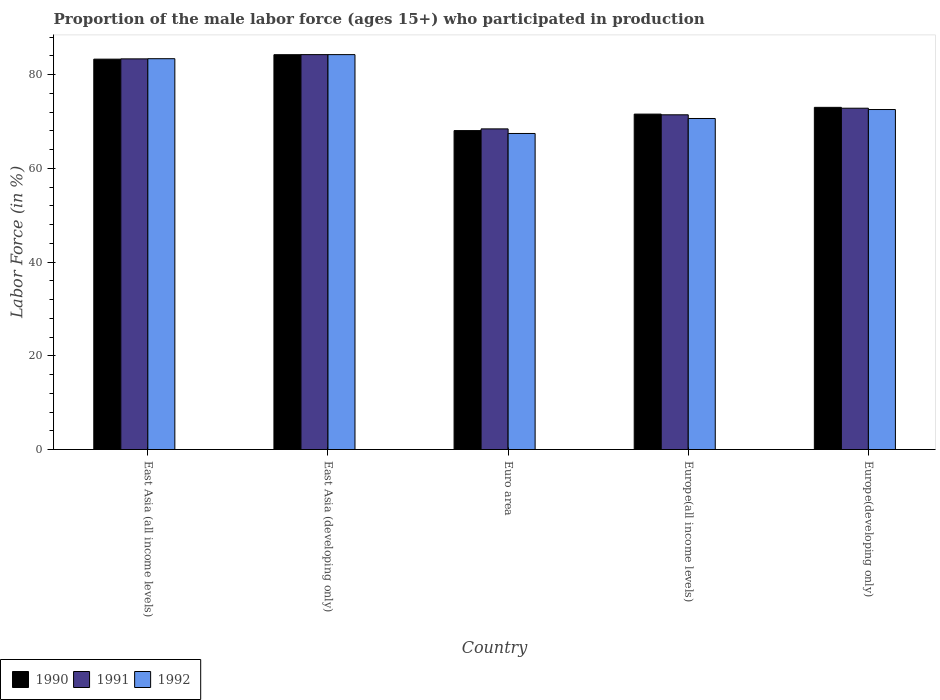How many bars are there on the 4th tick from the left?
Your answer should be very brief. 3. How many bars are there on the 5th tick from the right?
Offer a very short reply. 3. What is the label of the 5th group of bars from the left?
Give a very brief answer. Europe(developing only). In how many cases, is the number of bars for a given country not equal to the number of legend labels?
Your answer should be compact. 0. What is the proportion of the male labor force who participated in production in 1991 in East Asia (developing only)?
Keep it short and to the point. 84.25. Across all countries, what is the maximum proportion of the male labor force who participated in production in 1992?
Your response must be concise. 84.25. Across all countries, what is the minimum proportion of the male labor force who participated in production in 1992?
Ensure brevity in your answer.  67.42. In which country was the proportion of the male labor force who participated in production in 1990 maximum?
Offer a very short reply. East Asia (developing only). In which country was the proportion of the male labor force who participated in production in 1992 minimum?
Provide a short and direct response. Euro area. What is the total proportion of the male labor force who participated in production in 1991 in the graph?
Give a very brief answer. 380.22. What is the difference between the proportion of the male labor force who participated in production in 1990 in East Asia (all income levels) and that in Europe(developing only)?
Ensure brevity in your answer.  10.28. What is the difference between the proportion of the male labor force who participated in production in 1990 in Europe(developing only) and the proportion of the male labor force who participated in production in 1992 in Euro area?
Ensure brevity in your answer.  5.58. What is the average proportion of the male labor force who participated in production in 1991 per country?
Offer a very short reply. 76.04. What is the difference between the proportion of the male labor force who participated in production of/in 1991 and proportion of the male labor force who participated in production of/in 1990 in East Asia (all income levels)?
Your answer should be very brief. 0.06. In how many countries, is the proportion of the male labor force who participated in production in 1992 greater than 52 %?
Your answer should be very brief. 5. What is the ratio of the proportion of the male labor force who participated in production in 1990 in Euro area to that in Europe(all income levels)?
Keep it short and to the point. 0.95. Is the proportion of the male labor force who participated in production in 1992 in Euro area less than that in Europe(all income levels)?
Provide a short and direct response. Yes. What is the difference between the highest and the second highest proportion of the male labor force who participated in production in 1992?
Your answer should be compact. -10.85. What is the difference between the highest and the lowest proportion of the male labor force who participated in production in 1992?
Make the answer very short. 16.83. Is the sum of the proportion of the male labor force who participated in production in 1991 in East Asia (all income levels) and Euro area greater than the maximum proportion of the male labor force who participated in production in 1992 across all countries?
Your answer should be compact. Yes. What does the 2nd bar from the left in East Asia (developing only) represents?
Your answer should be very brief. 1991. What does the 1st bar from the right in Europe(developing only) represents?
Your response must be concise. 1992. How many bars are there?
Your response must be concise. 15. How many countries are there in the graph?
Give a very brief answer. 5. What is the difference between two consecutive major ticks on the Y-axis?
Your response must be concise. 20. Are the values on the major ticks of Y-axis written in scientific E-notation?
Offer a terse response. No. Does the graph contain any zero values?
Your response must be concise. No. Does the graph contain grids?
Your answer should be very brief. No. Where does the legend appear in the graph?
Your response must be concise. Bottom left. How many legend labels are there?
Ensure brevity in your answer.  3. What is the title of the graph?
Your answer should be compact. Proportion of the male labor force (ages 15+) who participated in production. What is the Labor Force (in %) of 1990 in East Asia (all income levels)?
Give a very brief answer. 83.28. What is the Labor Force (in %) in 1991 in East Asia (all income levels)?
Keep it short and to the point. 83.34. What is the Labor Force (in %) in 1992 in East Asia (all income levels)?
Your response must be concise. 83.38. What is the Labor Force (in %) in 1990 in East Asia (developing only)?
Your answer should be very brief. 84.23. What is the Labor Force (in %) in 1991 in East Asia (developing only)?
Provide a short and direct response. 84.25. What is the Labor Force (in %) in 1992 in East Asia (developing only)?
Your response must be concise. 84.25. What is the Labor Force (in %) in 1990 in Euro area?
Your answer should be very brief. 68.04. What is the Labor Force (in %) in 1991 in Euro area?
Provide a succinct answer. 68.4. What is the Labor Force (in %) in 1992 in Euro area?
Your answer should be compact. 67.42. What is the Labor Force (in %) of 1990 in Europe(all income levels)?
Offer a very short reply. 71.56. What is the Labor Force (in %) of 1991 in Europe(all income levels)?
Offer a terse response. 71.41. What is the Labor Force (in %) in 1992 in Europe(all income levels)?
Your answer should be compact. 70.62. What is the Labor Force (in %) of 1990 in Europe(developing only)?
Keep it short and to the point. 73. What is the Labor Force (in %) of 1991 in Europe(developing only)?
Provide a short and direct response. 72.82. What is the Labor Force (in %) in 1992 in Europe(developing only)?
Your answer should be very brief. 72.53. Across all countries, what is the maximum Labor Force (in %) in 1990?
Offer a terse response. 84.23. Across all countries, what is the maximum Labor Force (in %) of 1991?
Give a very brief answer. 84.25. Across all countries, what is the maximum Labor Force (in %) in 1992?
Your response must be concise. 84.25. Across all countries, what is the minimum Labor Force (in %) of 1990?
Offer a terse response. 68.04. Across all countries, what is the minimum Labor Force (in %) of 1991?
Ensure brevity in your answer.  68.4. Across all countries, what is the minimum Labor Force (in %) of 1992?
Offer a very short reply. 67.42. What is the total Labor Force (in %) in 1990 in the graph?
Ensure brevity in your answer.  380.12. What is the total Labor Force (in %) of 1991 in the graph?
Your answer should be compact. 380.22. What is the total Labor Force (in %) in 1992 in the graph?
Give a very brief answer. 378.21. What is the difference between the Labor Force (in %) of 1990 in East Asia (all income levels) and that in East Asia (developing only)?
Keep it short and to the point. -0.95. What is the difference between the Labor Force (in %) of 1991 in East Asia (all income levels) and that in East Asia (developing only)?
Provide a short and direct response. -0.91. What is the difference between the Labor Force (in %) in 1992 in East Asia (all income levels) and that in East Asia (developing only)?
Ensure brevity in your answer.  -0.87. What is the difference between the Labor Force (in %) of 1990 in East Asia (all income levels) and that in Euro area?
Your response must be concise. 15.24. What is the difference between the Labor Force (in %) of 1991 in East Asia (all income levels) and that in Euro area?
Provide a short and direct response. 14.94. What is the difference between the Labor Force (in %) in 1992 in East Asia (all income levels) and that in Euro area?
Give a very brief answer. 15.96. What is the difference between the Labor Force (in %) of 1990 in East Asia (all income levels) and that in Europe(all income levels)?
Your answer should be compact. 11.72. What is the difference between the Labor Force (in %) in 1991 in East Asia (all income levels) and that in Europe(all income levels)?
Keep it short and to the point. 11.93. What is the difference between the Labor Force (in %) of 1992 in East Asia (all income levels) and that in Europe(all income levels)?
Keep it short and to the point. 12.76. What is the difference between the Labor Force (in %) in 1990 in East Asia (all income levels) and that in Europe(developing only)?
Ensure brevity in your answer.  10.28. What is the difference between the Labor Force (in %) in 1991 in East Asia (all income levels) and that in Europe(developing only)?
Keep it short and to the point. 10.53. What is the difference between the Labor Force (in %) in 1992 in East Asia (all income levels) and that in Europe(developing only)?
Offer a very short reply. 10.85. What is the difference between the Labor Force (in %) of 1990 in East Asia (developing only) and that in Euro area?
Provide a short and direct response. 16.19. What is the difference between the Labor Force (in %) of 1991 in East Asia (developing only) and that in Euro area?
Your answer should be compact. 15.84. What is the difference between the Labor Force (in %) in 1992 in East Asia (developing only) and that in Euro area?
Keep it short and to the point. 16.83. What is the difference between the Labor Force (in %) in 1990 in East Asia (developing only) and that in Europe(all income levels)?
Provide a short and direct response. 12.67. What is the difference between the Labor Force (in %) of 1991 in East Asia (developing only) and that in Europe(all income levels)?
Your answer should be very brief. 12.84. What is the difference between the Labor Force (in %) in 1992 in East Asia (developing only) and that in Europe(all income levels)?
Give a very brief answer. 13.63. What is the difference between the Labor Force (in %) in 1990 in East Asia (developing only) and that in Europe(developing only)?
Your answer should be very brief. 11.23. What is the difference between the Labor Force (in %) in 1991 in East Asia (developing only) and that in Europe(developing only)?
Make the answer very short. 11.43. What is the difference between the Labor Force (in %) in 1992 in East Asia (developing only) and that in Europe(developing only)?
Offer a terse response. 11.71. What is the difference between the Labor Force (in %) in 1990 in Euro area and that in Europe(all income levels)?
Offer a very short reply. -3.52. What is the difference between the Labor Force (in %) of 1991 in Euro area and that in Europe(all income levels)?
Your response must be concise. -3. What is the difference between the Labor Force (in %) of 1992 in Euro area and that in Europe(all income levels)?
Make the answer very short. -3.2. What is the difference between the Labor Force (in %) of 1990 in Euro area and that in Europe(developing only)?
Keep it short and to the point. -4.96. What is the difference between the Labor Force (in %) of 1991 in Euro area and that in Europe(developing only)?
Keep it short and to the point. -4.41. What is the difference between the Labor Force (in %) of 1992 in Euro area and that in Europe(developing only)?
Make the answer very short. -5.11. What is the difference between the Labor Force (in %) in 1990 in Europe(all income levels) and that in Europe(developing only)?
Give a very brief answer. -1.44. What is the difference between the Labor Force (in %) of 1991 in Europe(all income levels) and that in Europe(developing only)?
Offer a very short reply. -1.41. What is the difference between the Labor Force (in %) in 1992 in Europe(all income levels) and that in Europe(developing only)?
Give a very brief answer. -1.91. What is the difference between the Labor Force (in %) of 1990 in East Asia (all income levels) and the Labor Force (in %) of 1991 in East Asia (developing only)?
Your answer should be compact. -0.97. What is the difference between the Labor Force (in %) of 1990 in East Asia (all income levels) and the Labor Force (in %) of 1992 in East Asia (developing only)?
Make the answer very short. -0.97. What is the difference between the Labor Force (in %) in 1991 in East Asia (all income levels) and the Labor Force (in %) in 1992 in East Asia (developing only)?
Offer a very short reply. -0.91. What is the difference between the Labor Force (in %) of 1990 in East Asia (all income levels) and the Labor Force (in %) of 1991 in Euro area?
Provide a succinct answer. 14.88. What is the difference between the Labor Force (in %) of 1990 in East Asia (all income levels) and the Labor Force (in %) of 1992 in Euro area?
Your answer should be very brief. 15.86. What is the difference between the Labor Force (in %) of 1991 in East Asia (all income levels) and the Labor Force (in %) of 1992 in Euro area?
Keep it short and to the point. 15.92. What is the difference between the Labor Force (in %) of 1990 in East Asia (all income levels) and the Labor Force (in %) of 1991 in Europe(all income levels)?
Offer a very short reply. 11.87. What is the difference between the Labor Force (in %) of 1990 in East Asia (all income levels) and the Labor Force (in %) of 1992 in Europe(all income levels)?
Provide a succinct answer. 12.66. What is the difference between the Labor Force (in %) of 1991 in East Asia (all income levels) and the Labor Force (in %) of 1992 in Europe(all income levels)?
Keep it short and to the point. 12.72. What is the difference between the Labor Force (in %) in 1990 in East Asia (all income levels) and the Labor Force (in %) in 1991 in Europe(developing only)?
Provide a short and direct response. 10.47. What is the difference between the Labor Force (in %) in 1990 in East Asia (all income levels) and the Labor Force (in %) in 1992 in Europe(developing only)?
Provide a succinct answer. 10.75. What is the difference between the Labor Force (in %) of 1991 in East Asia (all income levels) and the Labor Force (in %) of 1992 in Europe(developing only)?
Offer a very short reply. 10.81. What is the difference between the Labor Force (in %) of 1990 in East Asia (developing only) and the Labor Force (in %) of 1991 in Euro area?
Make the answer very short. 15.83. What is the difference between the Labor Force (in %) in 1990 in East Asia (developing only) and the Labor Force (in %) in 1992 in Euro area?
Ensure brevity in your answer.  16.81. What is the difference between the Labor Force (in %) of 1991 in East Asia (developing only) and the Labor Force (in %) of 1992 in Euro area?
Your answer should be compact. 16.82. What is the difference between the Labor Force (in %) in 1990 in East Asia (developing only) and the Labor Force (in %) in 1991 in Europe(all income levels)?
Provide a succinct answer. 12.82. What is the difference between the Labor Force (in %) of 1990 in East Asia (developing only) and the Labor Force (in %) of 1992 in Europe(all income levels)?
Offer a terse response. 13.61. What is the difference between the Labor Force (in %) in 1991 in East Asia (developing only) and the Labor Force (in %) in 1992 in Europe(all income levels)?
Offer a terse response. 13.63. What is the difference between the Labor Force (in %) in 1990 in East Asia (developing only) and the Labor Force (in %) in 1991 in Europe(developing only)?
Make the answer very short. 11.42. What is the difference between the Labor Force (in %) of 1990 in East Asia (developing only) and the Labor Force (in %) of 1992 in Europe(developing only)?
Your answer should be very brief. 11.7. What is the difference between the Labor Force (in %) in 1991 in East Asia (developing only) and the Labor Force (in %) in 1992 in Europe(developing only)?
Keep it short and to the point. 11.71. What is the difference between the Labor Force (in %) in 1990 in Euro area and the Labor Force (in %) in 1991 in Europe(all income levels)?
Provide a short and direct response. -3.37. What is the difference between the Labor Force (in %) of 1990 in Euro area and the Labor Force (in %) of 1992 in Europe(all income levels)?
Your answer should be very brief. -2.58. What is the difference between the Labor Force (in %) in 1991 in Euro area and the Labor Force (in %) in 1992 in Europe(all income levels)?
Offer a very short reply. -2.22. What is the difference between the Labor Force (in %) in 1990 in Euro area and the Labor Force (in %) in 1991 in Europe(developing only)?
Offer a terse response. -4.78. What is the difference between the Labor Force (in %) in 1990 in Euro area and the Labor Force (in %) in 1992 in Europe(developing only)?
Your answer should be very brief. -4.49. What is the difference between the Labor Force (in %) of 1991 in Euro area and the Labor Force (in %) of 1992 in Europe(developing only)?
Your answer should be compact. -4.13. What is the difference between the Labor Force (in %) in 1990 in Europe(all income levels) and the Labor Force (in %) in 1991 in Europe(developing only)?
Your answer should be compact. -1.26. What is the difference between the Labor Force (in %) of 1990 in Europe(all income levels) and the Labor Force (in %) of 1992 in Europe(developing only)?
Your answer should be compact. -0.97. What is the difference between the Labor Force (in %) of 1991 in Europe(all income levels) and the Labor Force (in %) of 1992 in Europe(developing only)?
Your response must be concise. -1.12. What is the average Labor Force (in %) in 1990 per country?
Your answer should be compact. 76.02. What is the average Labor Force (in %) in 1991 per country?
Provide a short and direct response. 76.04. What is the average Labor Force (in %) in 1992 per country?
Your answer should be very brief. 75.64. What is the difference between the Labor Force (in %) of 1990 and Labor Force (in %) of 1991 in East Asia (all income levels)?
Provide a succinct answer. -0.06. What is the difference between the Labor Force (in %) of 1990 and Labor Force (in %) of 1992 in East Asia (all income levels)?
Provide a short and direct response. -0.1. What is the difference between the Labor Force (in %) of 1991 and Labor Force (in %) of 1992 in East Asia (all income levels)?
Keep it short and to the point. -0.04. What is the difference between the Labor Force (in %) in 1990 and Labor Force (in %) in 1991 in East Asia (developing only)?
Your answer should be compact. -0.02. What is the difference between the Labor Force (in %) in 1990 and Labor Force (in %) in 1992 in East Asia (developing only)?
Provide a succinct answer. -0.02. What is the difference between the Labor Force (in %) of 1991 and Labor Force (in %) of 1992 in East Asia (developing only)?
Offer a terse response. -0. What is the difference between the Labor Force (in %) in 1990 and Labor Force (in %) in 1991 in Euro area?
Provide a succinct answer. -0.36. What is the difference between the Labor Force (in %) of 1990 and Labor Force (in %) of 1992 in Euro area?
Your answer should be very brief. 0.62. What is the difference between the Labor Force (in %) of 1991 and Labor Force (in %) of 1992 in Euro area?
Offer a terse response. 0.98. What is the difference between the Labor Force (in %) in 1990 and Labor Force (in %) in 1991 in Europe(all income levels)?
Your answer should be very brief. 0.15. What is the difference between the Labor Force (in %) in 1990 and Labor Force (in %) in 1992 in Europe(all income levels)?
Offer a very short reply. 0.94. What is the difference between the Labor Force (in %) in 1991 and Labor Force (in %) in 1992 in Europe(all income levels)?
Give a very brief answer. 0.79. What is the difference between the Labor Force (in %) in 1990 and Labor Force (in %) in 1991 in Europe(developing only)?
Offer a terse response. 0.18. What is the difference between the Labor Force (in %) in 1990 and Labor Force (in %) in 1992 in Europe(developing only)?
Make the answer very short. 0.47. What is the difference between the Labor Force (in %) of 1991 and Labor Force (in %) of 1992 in Europe(developing only)?
Give a very brief answer. 0.28. What is the ratio of the Labor Force (in %) of 1990 in East Asia (all income levels) to that in East Asia (developing only)?
Your answer should be very brief. 0.99. What is the ratio of the Labor Force (in %) of 1991 in East Asia (all income levels) to that in East Asia (developing only)?
Provide a succinct answer. 0.99. What is the ratio of the Labor Force (in %) in 1992 in East Asia (all income levels) to that in East Asia (developing only)?
Provide a succinct answer. 0.99. What is the ratio of the Labor Force (in %) in 1990 in East Asia (all income levels) to that in Euro area?
Ensure brevity in your answer.  1.22. What is the ratio of the Labor Force (in %) of 1991 in East Asia (all income levels) to that in Euro area?
Make the answer very short. 1.22. What is the ratio of the Labor Force (in %) of 1992 in East Asia (all income levels) to that in Euro area?
Your answer should be compact. 1.24. What is the ratio of the Labor Force (in %) of 1990 in East Asia (all income levels) to that in Europe(all income levels)?
Provide a succinct answer. 1.16. What is the ratio of the Labor Force (in %) of 1991 in East Asia (all income levels) to that in Europe(all income levels)?
Ensure brevity in your answer.  1.17. What is the ratio of the Labor Force (in %) of 1992 in East Asia (all income levels) to that in Europe(all income levels)?
Give a very brief answer. 1.18. What is the ratio of the Labor Force (in %) of 1990 in East Asia (all income levels) to that in Europe(developing only)?
Ensure brevity in your answer.  1.14. What is the ratio of the Labor Force (in %) in 1991 in East Asia (all income levels) to that in Europe(developing only)?
Your answer should be very brief. 1.14. What is the ratio of the Labor Force (in %) of 1992 in East Asia (all income levels) to that in Europe(developing only)?
Provide a short and direct response. 1.15. What is the ratio of the Labor Force (in %) of 1990 in East Asia (developing only) to that in Euro area?
Keep it short and to the point. 1.24. What is the ratio of the Labor Force (in %) in 1991 in East Asia (developing only) to that in Euro area?
Your answer should be compact. 1.23. What is the ratio of the Labor Force (in %) in 1992 in East Asia (developing only) to that in Euro area?
Make the answer very short. 1.25. What is the ratio of the Labor Force (in %) of 1990 in East Asia (developing only) to that in Europe(all income levels)?
Offer a very short reply. 1.18. What is the ratio of the Labor Force (in %) of 1991 in East Asia (developing only) to that in Europe(all income levels)?
Keep it short and to the point. 1.18. What is the ratio of the Labor Force (in %) in 1992 in East Asia (developing only) to that in Europe(all income levels)?
Offer a terse response. 1.19. What is the ratio of the Labor Force (in %) of 1990 in East Asia (developing only) to that in Europe(developing only)?
Give a very brief answer. 1.15. What is the ratio of the Labor Force (in %) of 1991 in East Asia (developing only) to that in Europe(developing only)?
Your answer should be compact. 1.16. What is the ratio of the Labor Force (in %) in 1992 in East Asia (developing only) to that in Europe(developing only)?
Your answer should be very brief. 1.16. What is the ratio of the Labor Force (in %) in 1990 in Euro area to that in Europe(all income levels)?
Offer a very short reply. 0.95. What is the ratio of the Labor Force (in %) of 1991 in Euro area to that in Europe(all income levels)?
Provide a short and direct response. 0.96. What is the ratio of the Labor Force (in %) of 1992 in Euro area to that in Europe(all income levels)?
Offer a terse response. 0.95. What is the ratio of the Labor Force (in %) in 1990 in Euro area to that in Europe(developing only)?
Keep it short and to the point. 0.93. What is the ratio of the Labor Force (in %) of 1991 in Euro area to that in Europe(developing only)?
Provide a succinct answer. 0.94. What is the ratio of the Labor Force (in %) in 1992 in Euro area to that in Europe(developing only)?
Your answer should be very brief. 0.93. What is the ratio of the Labor Force (in %) of 1990 in Europe(all income levels) to that in Europe(developing only)?
Make the answer very short. 0.98. What is the ratio of the Labor Force (in %) in 1991 in Europe(all income levels) to that in Europe(developing only)?
Provide a succinct answer. 0.98. What is the ratio of the Labor Force (in %) of 1992 in Europe(all income levels) to that in Europe(developing only)?
Your response must be concise. 0.97. What is the difference between the highest and the second highest Labor Force (in %) in 1990?
Make the answer very short. 0.95. What is the difference between the highest and the second highest Labor Force (in %) of 1991?
Provide a short and direct response. 0.91. What is the difference between the highest and the second highest Labor Force (in %) in 1992?
Offer a very short reply. 0.87. What is the difference between the highest and the lowest Labor Force (in %) of 1990?
Keep it short and to the point. 16.19. What is the difference between the highest and the lowest Labor Force (in %) of 1991?
Provide a succinct answer. 15.84. What is the difference between the highest and the lowest Labor Force (in %) in 1992?
Make the answer very short. 16.83. 